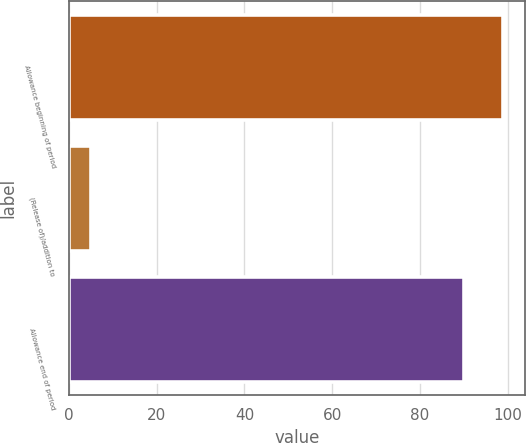Convert chart to OTSL. <chart><loc_0><loc_0><loc_500><loc_500><bar_chart><fcel>Allowance beginning of period<fcel>(Release of)/addition to<fcel>Allowance end of period<nl><fcel>98.9<fcel>5<fcel>90<nl></chart> 